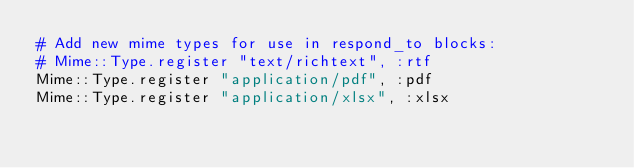Convert code to text. <code><loc_0><loc_0><loc_500><loc_500><_Ruby_># Add new mime types for use in respond_to blocks:
# Mime::Type.register "text/richtext", :rtf
Mime::Type.register "application/pdf", :pdf
Mime::Type.register "application/xlsx", :xlsx

</code> 